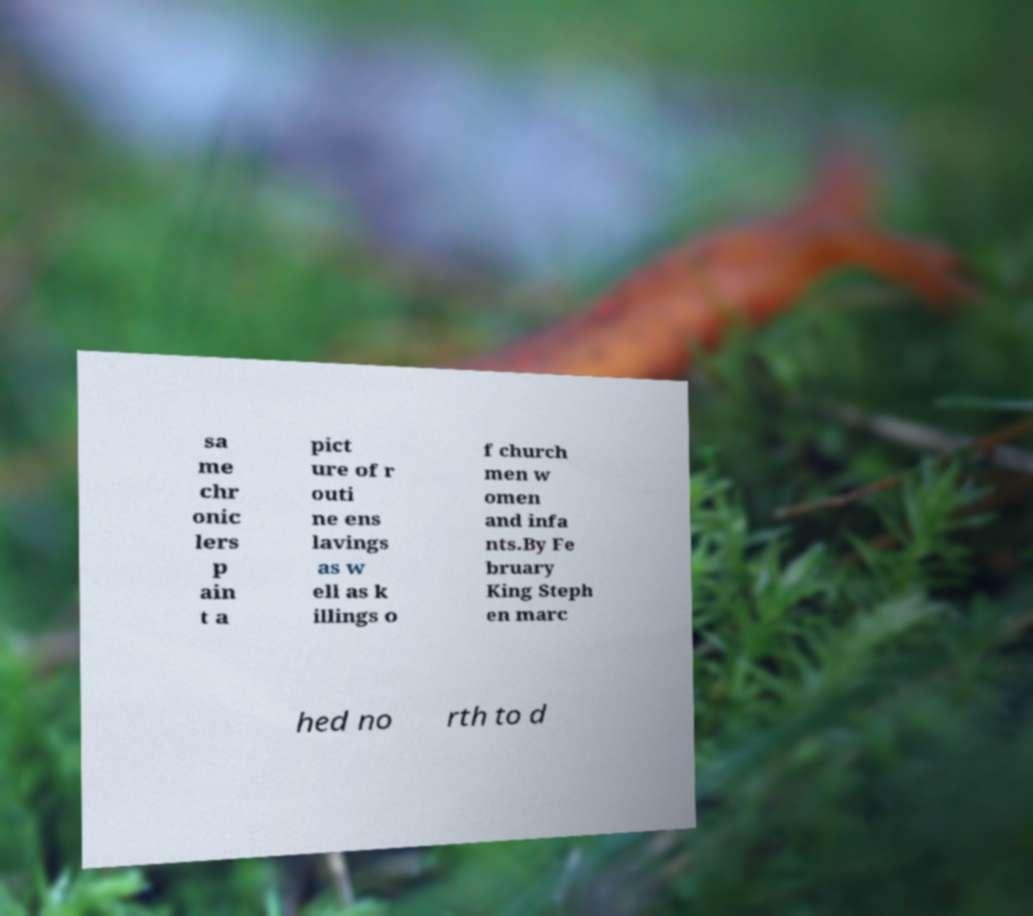Please identify and transcribe the text found in this image. sa me chr onic lers p ain t a pict ure of r outi ne ens lavings as w ell as k illings o f church men w omen and infa nts.By Fe bruary King Steph en marc hed no rth to d 